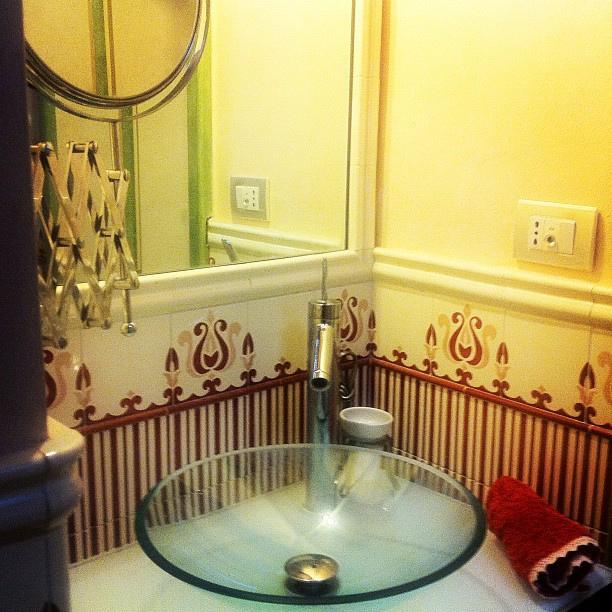What is the sink made out of?
Answer briefly. Glass. Is anyone in the bathroom?
Concise answer only. No. Is there a mirror on the wall?
Give a very brief answer. Yes. 